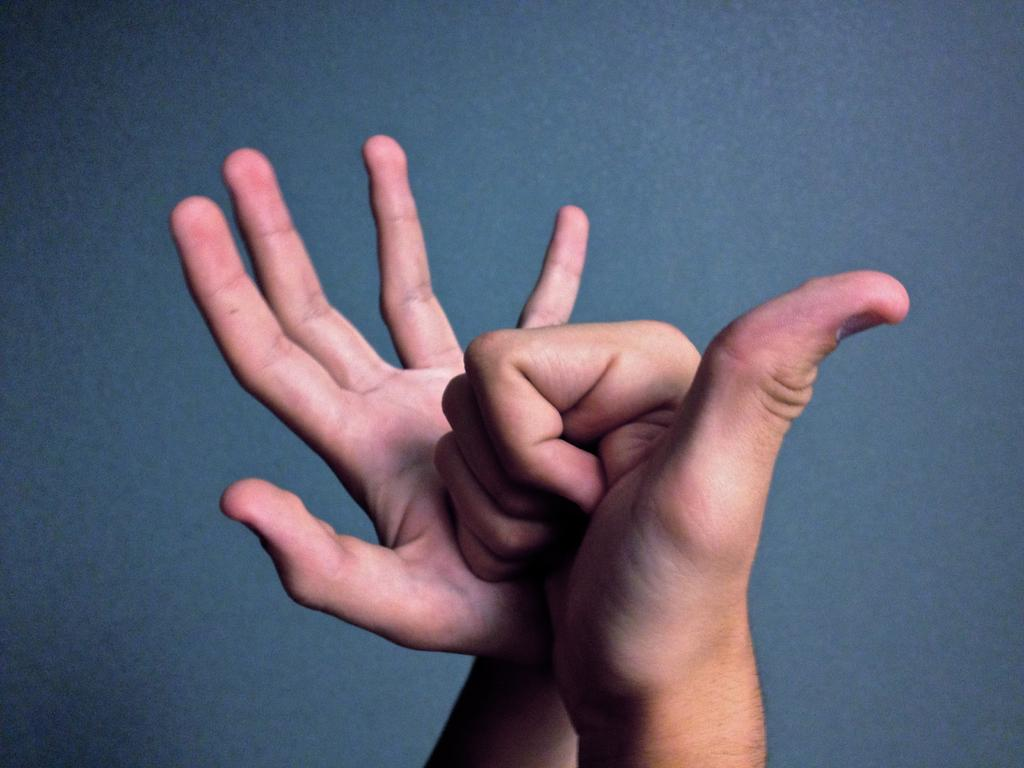What is the main subject of the image? The main subject of the image is the hands of a person. What can be seen in the background of the image? There is a wall in the background of the image. What type of harmony is being played by the fowl in the image? There is no fowl or harmony present in the image; it only features the hands of a person and a wall in the background. 